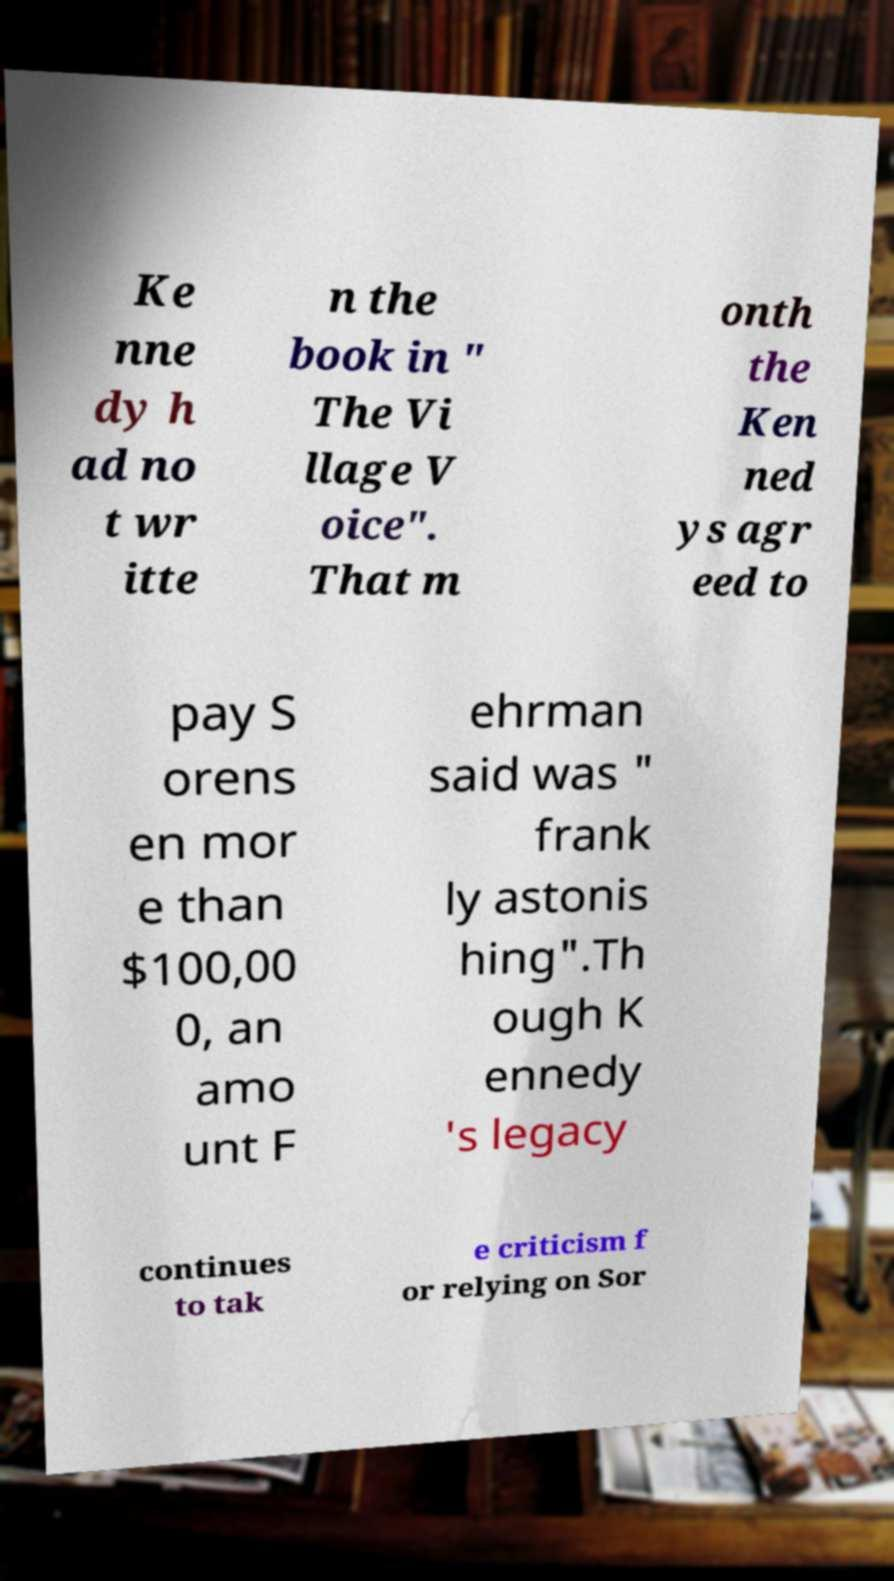Please identify and transcribe the text found in this image. Ke nne dy h ad no t wr itte n the book in " The Vi llage V oice". That m onth the Ken ned ys agr eed to pay S orens en mor e than $100,00 0, an amo unt F ehrman said was " frank ly astonis hing".Th ough K ennedy 's legacy continues to tak e criticism f or relying on Sor 